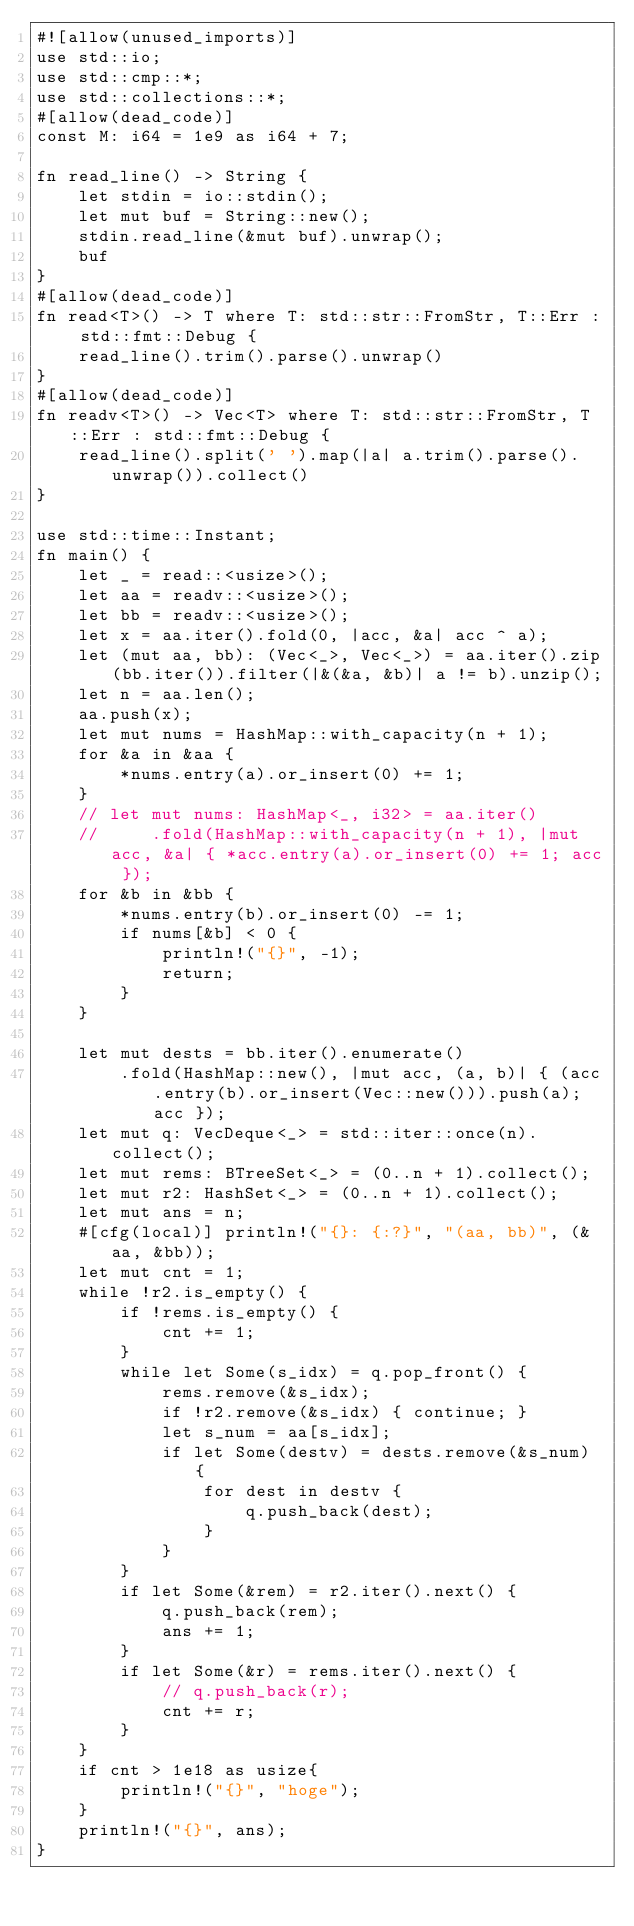Convert code to text. <code><loc_0><loc_0><loc_500><loc_500><_Rust_>#![allow(unused_imports)]
use std::io;
use std::cmp::*;
use std::collections::*;
#[allow(dead_code)]
const M: i64 = 1e9 as i64 + 7;

fn read_line() -> String {
    let stdin = io::stdin();
    let mut buf = String::new();
    stdin.read_line(&mut buf).unwrap();
    buf
}
#[allow(dead_code)]
fn read<T>() -> T where T: std::str::FromStr, T::Err : std::fmt::Debug {
    read_line().trim().parse().unwrap()
}
#[allow(dead_code)]
fn readv<T>() -> Vec<T> where T: std::str::FromStr, T::Err : std::fmt::Debug {
    read_line().split(' ').map(|a| a.trim().parse().unwrap()).collect()
}

use std::time::Instant;
fn main() {
    let _ = read::<usize>();
    let aa = readv::<usize>();
    let bb = readv::<usize>();
    let x = aa.iter().fold(0, |acc, &a| acc ^ a);
    let (mut aa, bb): (Vec<_>, Vec<_>) = aa.iter().zip(bb.iter()).filter(|&(&a, &b)| a != b).unzip();
    let n = aa.len();
    aa.push(x);
    let mut nums = HashMap::with_capacity(n + 1);
    for &a in &aa {
        *nums.entry(a).or_insert(0) += 1;
    }
    // let mut nums: HashMap<_, i32> = aa.iter()
    //     .fold(HashMap::with_capacity(n + 1), |mut acc, &a| { *acc.entry(a).or_insert(0) += 1; acc });
    for &b in &bb {
        *nums.entry(b).or_insert(0) -= 1;
        if nums[&b] < 0 {
            println!("{}", -1);
            return;
        }
    }

    let mut dests = bb.iter().enumerate()
        .fold(HashMap::new(), |mut acc, (a, b)| { (acc.entry(b).or_insert(Vec::new())).push(a); acc });
    let mut q: VecDeque<_> = std::iter::once(n).collect();
    let mut rems: BTreeSet<_> = (0..n + 1).collect();
    let mut r2: HashSet<_> = (0..n + 1).collect();
    let mut ans = n;
    #[cfg(local)] println!("{}: {:?}", "(aa, bb)", (&aa, &bb));
    let mut cnt = 1;
    while !r2.is_empty() {
        if !rems.is_empty() {
            cnt += 1;
        }
        while let Some(s_idx) = q.pop_front() {
            rems.remove(&s_idx);
            if !r2.remove(&s_idx) { continue; }
            let s_num = aa[s_idx];
            if let Some(destv) = dests.remove(&s_num) {
                for dest in destv {
                    q.push_back(dest);
                }
            }
        }
        if let Some(&rem) = r2.iter().next() {
            q.push_back(rem);
            ans += 1;
        }
        if let Some(&r) = rems.iter().next() {
            // q.push_back(r);
            cnt += r;
        }
    }
    if cnt > 1e18 as usize{
        println!("{}", "hoge");
    }
    println!("{}", ans);
}
</code> 